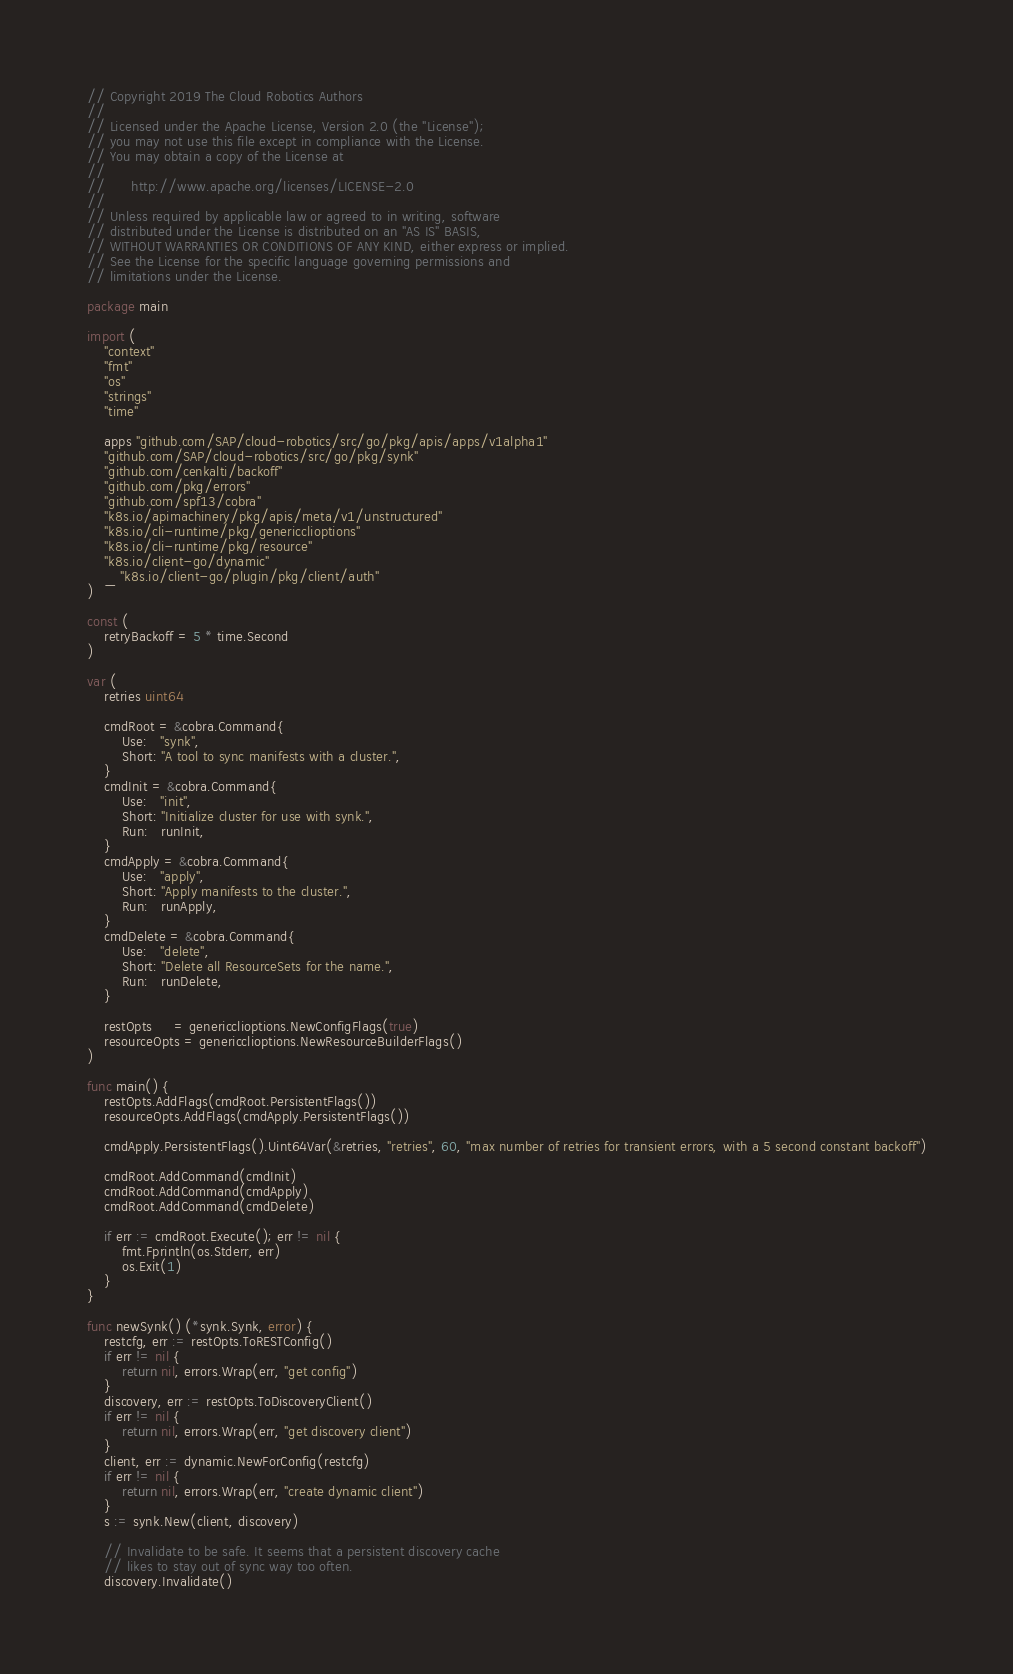<code> <loc_0><loc_0><loc_500><loc_500><_Go_>// Copyright 2019 The Cloud Robotics Authors
//
// Licensed under the Apache License, Version 2.0 (the "License");
// you may not use this file except in compliance with the License.
// You may obtain a copy of the License at
//
//      http://www.apache.org/licenses/LICENSE-2.0
//
// Unless required by applicable law or agreed to in writing, software
// distributed under the License is distributed on an "AS IS" BASIS,
// WITHOUT WARRANTIES OR CONDITIONS OF ANY KIND, either express or implied.
// See the License for the specific language governing permissions and
// limitations under the License.

package main

import (
	"context"
	"fmt"
	"os"
	"strings"
	"time"

	apps "github.com/SAP/cloud-robotics/src/go/pkg/apis/apps/v1alpha1"
	"github.com/SAP/cloud-robotics/src/go/pkg/synk"
	"github.com/cenkalti/backoff"
	"github.com/pkg/errors"
	"github.com/spf13/cobra"
	"k8s.io/apimachinery/pkg/apis/meta/v1/unstructured"
	"k8s.io/cli-runtime/pkg/genericclioptions"
	"k8s.io/cli-runtime/pkg/resource"
	"k8s.io/client-go/dynamic"
	_ "k8s.io/client-go/plugin/pkg/client/auth"
)

const (
	retryBackoff = 5 * time.Second
)

var (
	retries uint64

	cmdRoot = &cobra.Command{
		Use:   "synk",
		Short: "A tool to sync manifests with a cluster.",
	}
	cmdInit = &cobra.Command{
		Use:   "init",
		Short: "Initialize cluster for use with synk.",
		Run:   runInit,
	}
	cmdApply = &cobra.Command{
		Use:   "apply",
		Short: "Apply manifests to the cluster.",
		Run:   runApply,
	}
	cmdDelete = &cobra.Command{
		Use:   "delete",
		Short: "Delete all ResourceSets for the name.",
		Run:   runDelete,
	}

	restOpts     = genericclioptions.NewConfigFlags(true)
	resourceOpts = genericclioptions.NewResourceBuilderFlags()
)

func main() {
	restOpts.AddFlags(cmdRoot.PersistentFlags())
	resourceOpts.AddFlags(cmdApply.PersistentFlags())

	cmdApply.PersistentFlags().Uint64Var(&retries, "retries", 60, "max number of retries for transient errors, with a 5 second constant backoff")

	cmdRoot.AddCommand(cmdInit)
	cmdRoot.AddCommand(cmdApply)
	cmdRoot.AddCommand(cmdDelete)

	if err := cmdRoot.Execute(); err != nil {
		fmt.Fprintln(os.Stderr, err)
		os.Exit(1)
	}
}

func newSynk() (*synk.Synk, error) {
	restcfg, err := restOpts.ToRESTConfig()
	if err != nil {
		return nil, errors.Wrap(err, "get config")
	}
	discovery, err := restOpts.ToDiscoveryClient()
	if err != nil {
		return nil, errors.Wrap(err, "get discovery client")
	}
	client, err := dynamic.NewForConfig(restcfg)
	if err != nil {
		return nil, errors.Wrap(err, "create dynamic client")
	}
	s := synk.New(client, discovery)

	// Invalidate to be safe. It seems that a persistent discovery cache
	// likes to stay out of sync way too often.
	discovery.Invalidate()
</code> 